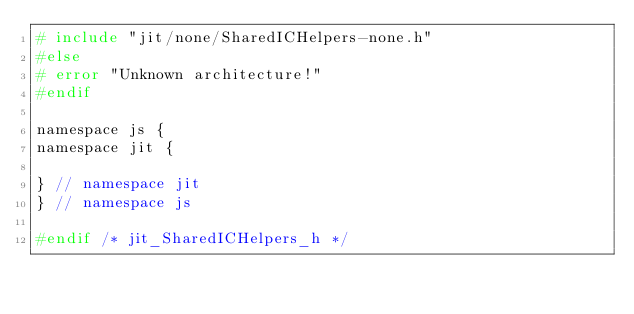Convert code to text. <code><loc_0><loc_0><loc_500><loc_500><_C_># include "jit/none/SharedICHelpers-none.h"
#else
# error "Unknown architecture!"
#endif

namespace js {
namespace jit {

} // namespace jit
} // namespace js

#endif /* jit_SharedICHelpers_h */
</code> 